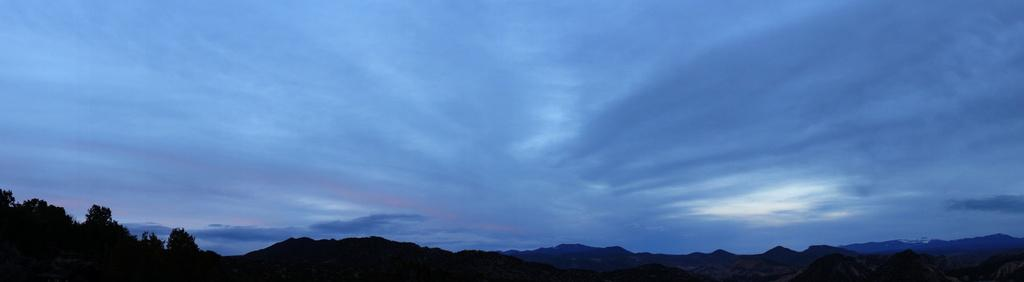What type of natural features can be seen in the image? There are trees and mountains in the image. What part of the natural environment is visible in the image? The sky is visible in the image. How would you describe the sky in the image? The sky is cloudy in the image. How would you describe the overall lighting in the image? The image appears to be dark. What type of lettuce is growing on the canvas in the image? There is no lettuce or canvas present in the image. How many bells can be seen hanging from the trees in the image? There are no bells present in the image; it features trees, mountains, and a cloudy sky. 